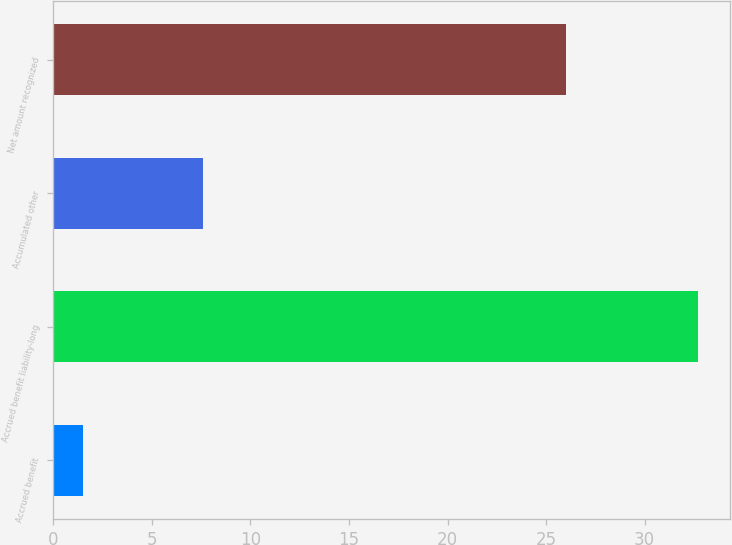Convert chart to OTSL. <chart><loc_0><loc_0><loc_500><loc_500><bar_chart><fcel>Accrued benefit<fcel>Accrued benefit liability-long<fcel>Accumulated other<fcel>Net amount recognized<nl><fcel>1.5<fcel>32.7<fcel>7.6<fcel>26<nl></chart> 